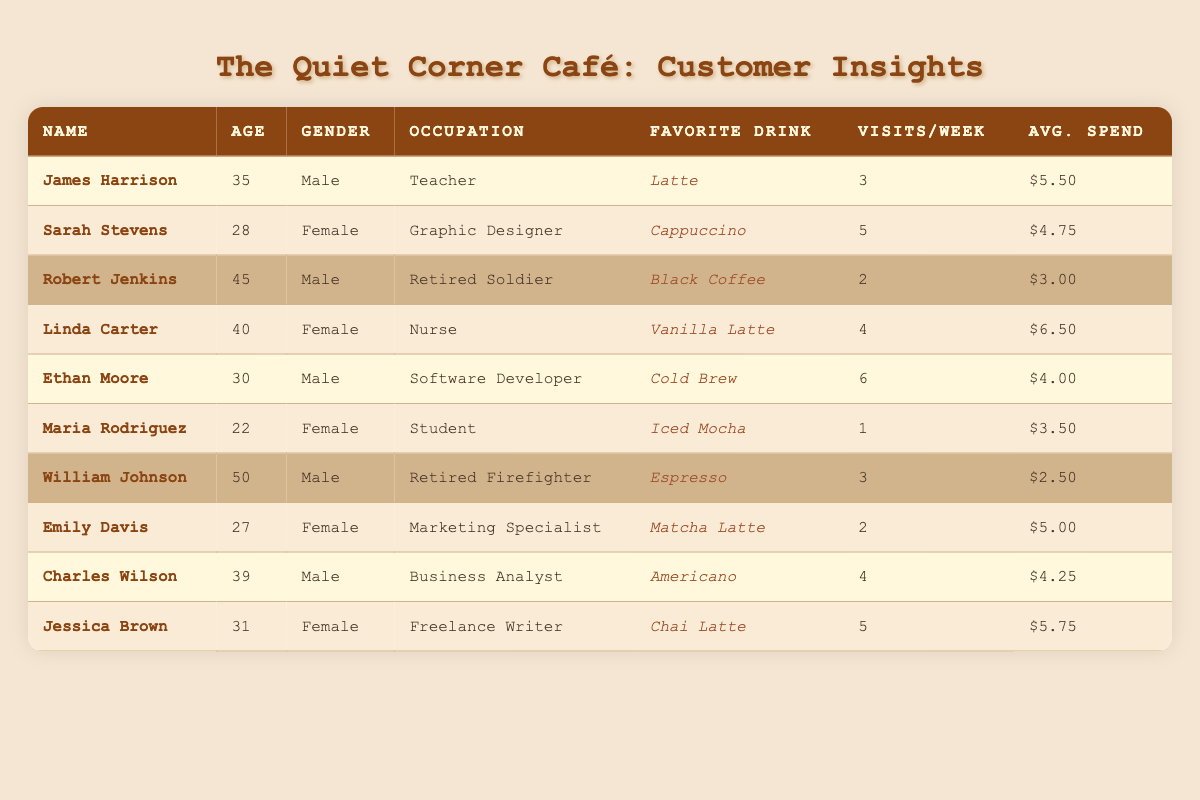What is the favorite drink of Ethan Moore? Ethan Moore's favorite drink is listed in the table as Cold Brew.
Answer: Cold Brew How many times per week does James Harrison visit the coffee shop? James Harrison's purchase frequency per week is indicated in the table as 3 visits.
Answer: 3 What is the average spend per visit for Linda Carter? The average spend per visit for Linda Carter is shown in the table as $6.50.
Answer: $6.50 Which customer has the highest purchase frequency per week? By reviewing the purchase frequency column, Ethan Moore has the highest frequency at 6 visits per week.
Answer: Ethan Moore Are there any female customers whose favorite drink is Chai Latte? The table shows that Jessica Brown's favorite drink is Chai Latte, and she is female.
Answer: Yes What is the average age of customers who have a military background? The military background customers are Robert Jenkins (45) and William Johnson (50). Average age is (45 + 50)/2 = 47.5.
Answer: 47.5 How much does Sarah Stevens spend per visit compared to Robert Jenkins? Sarah Stevens spends $4.75 per visit, while Robert Jenkins spends $3.00. The difference is $4.75 - $3.00 = $1.75 more than Robert Jenkins.
Answer: $1.75 How many total visits do Jessica Brown and Charles Wilson make to the coffee shop in a week? Jessica Brown visits 5 times a week, and Charles Wilson visits 4 times a week. Total visits = 5 + 4 = 9.
Answer: 9 Which customer spends the least per visit? By checking the average spend per visit, William Johnson spends $2.50, which is the least among all customers.
Answer: William Johnson Is there any customer who visits the coffee shop only once a week? The table shows that Maria Rodriguez visits only once a week.
Answer: Yes What is the median age of all customers in the table? The ages sorted are 22, 27, 28, 30, 31, 35, 39, 40, 45, 50. There are 10 customers, so the median is the average of the 5th and 6th ages: (31 + 35)/2 = 33.
Answer: 33 